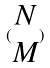Convert formula to latex. <formula><loc_0><loc_0><loc_500><loc_500>( \begin{matrix} N \\ M \end{matrix} )</formula> 